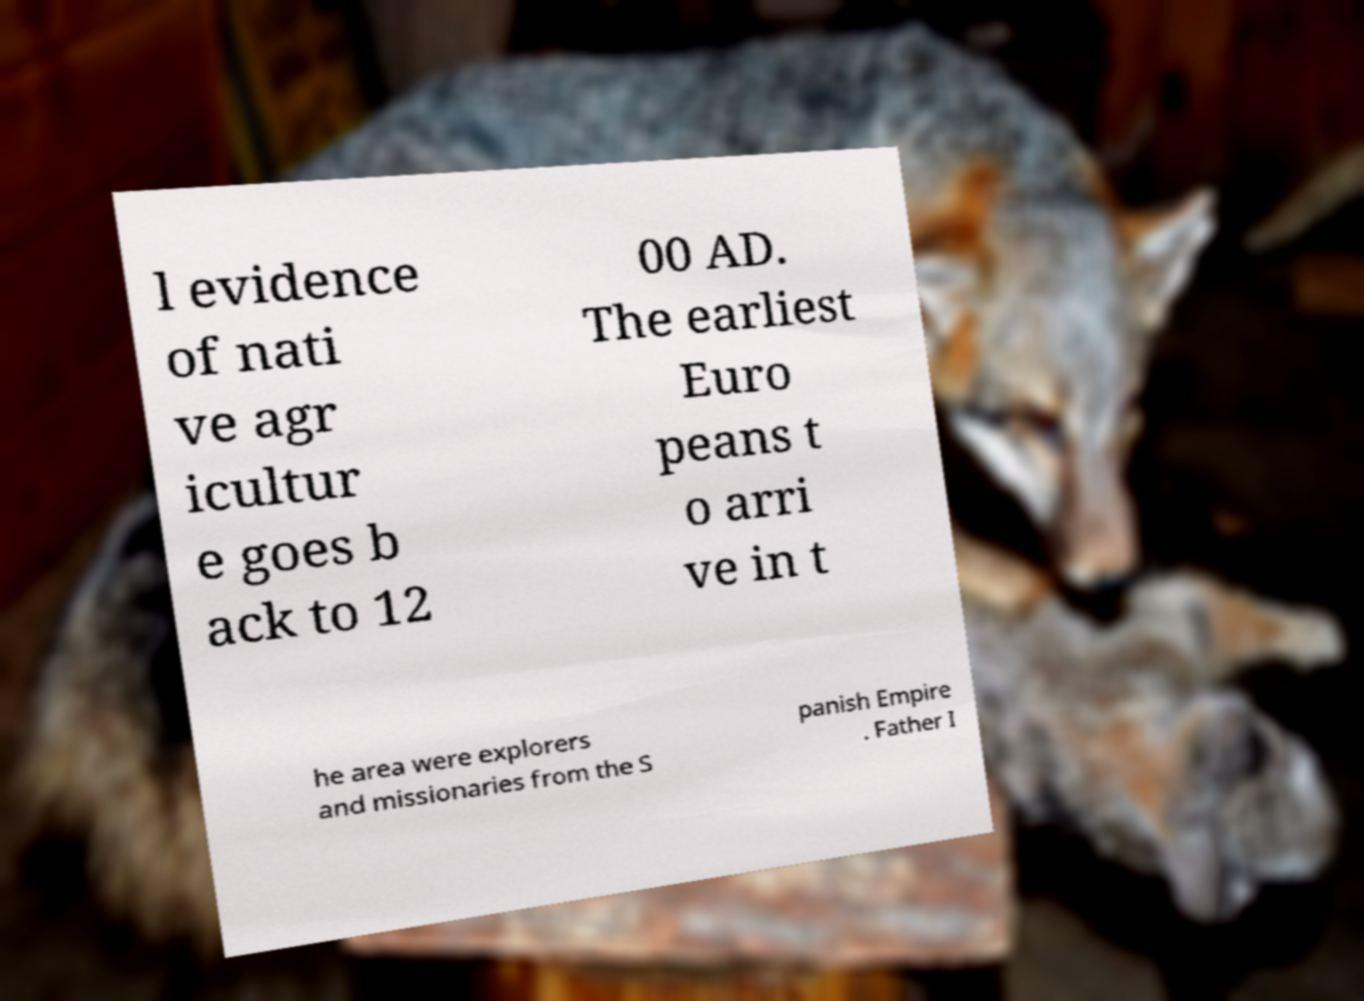Could you assist in decoding the text presented in this image and type it out clearly? l evidence of nati ve agr icultur e goes b ack to 12 00 AD. The earliest Euro peans t o arri ve in t he area were explorers and missionaries from the S panish Empire . Father I 